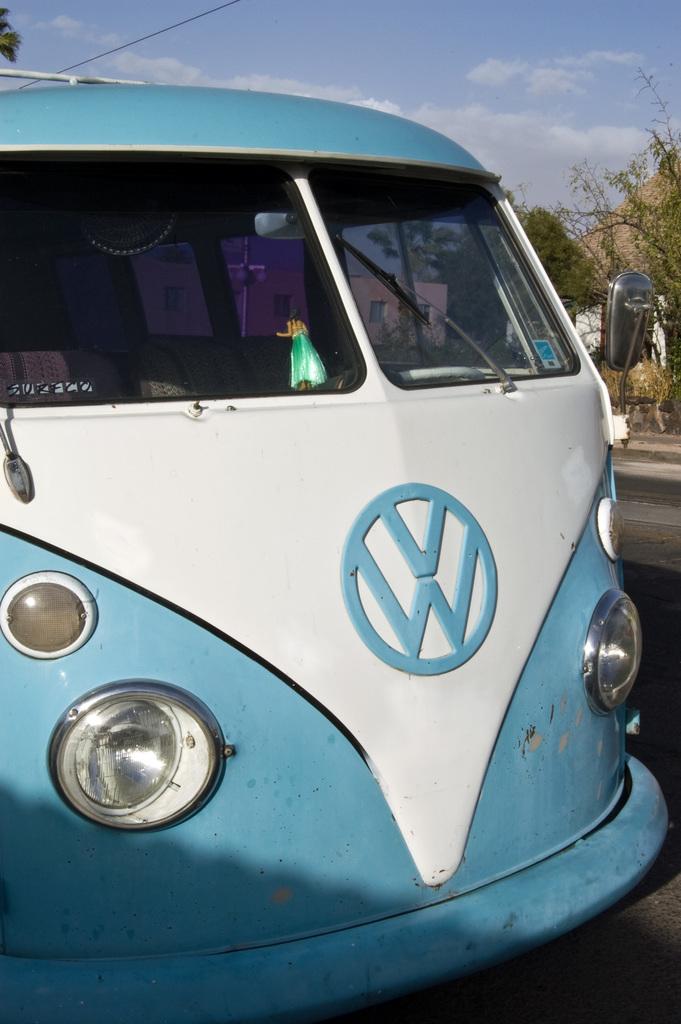What kind of bus is this?
Keep it short and to the point. Vw. 